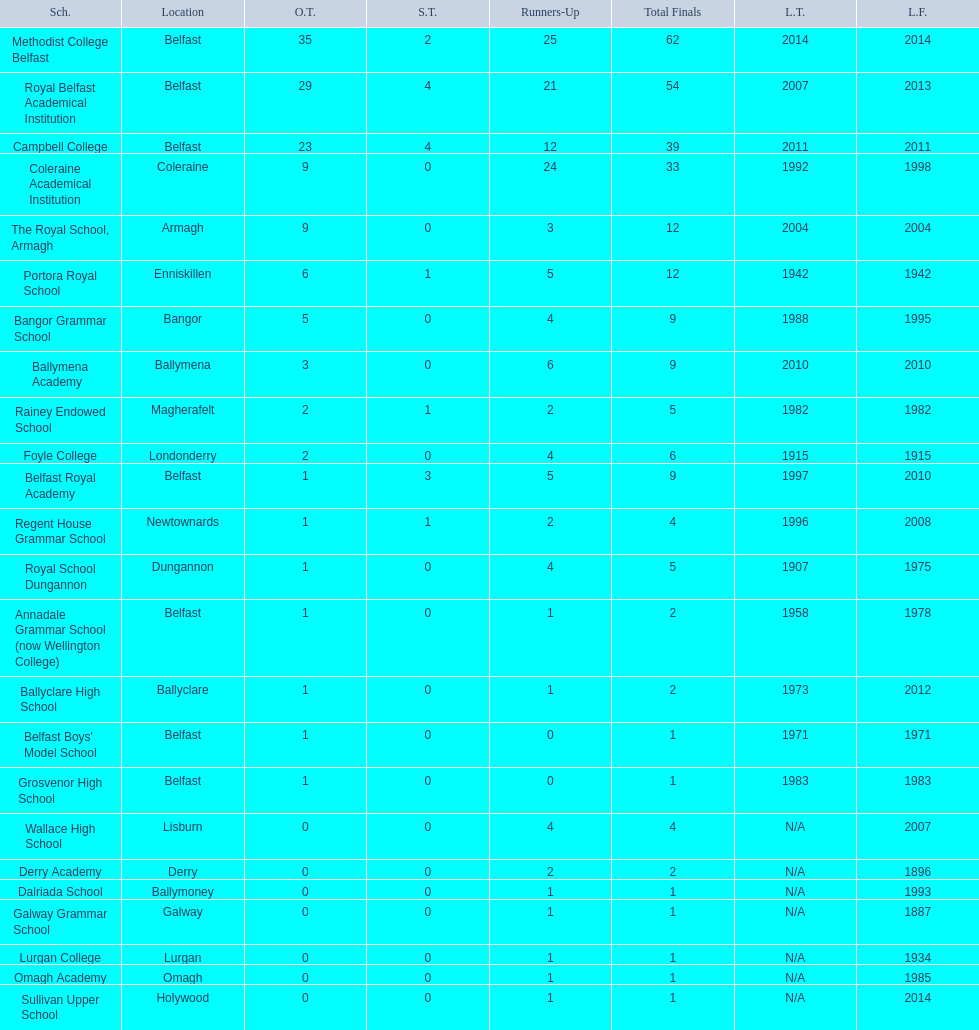Between campbell college and regent house grammar school, who possesses the newest title success? Campbell College. 